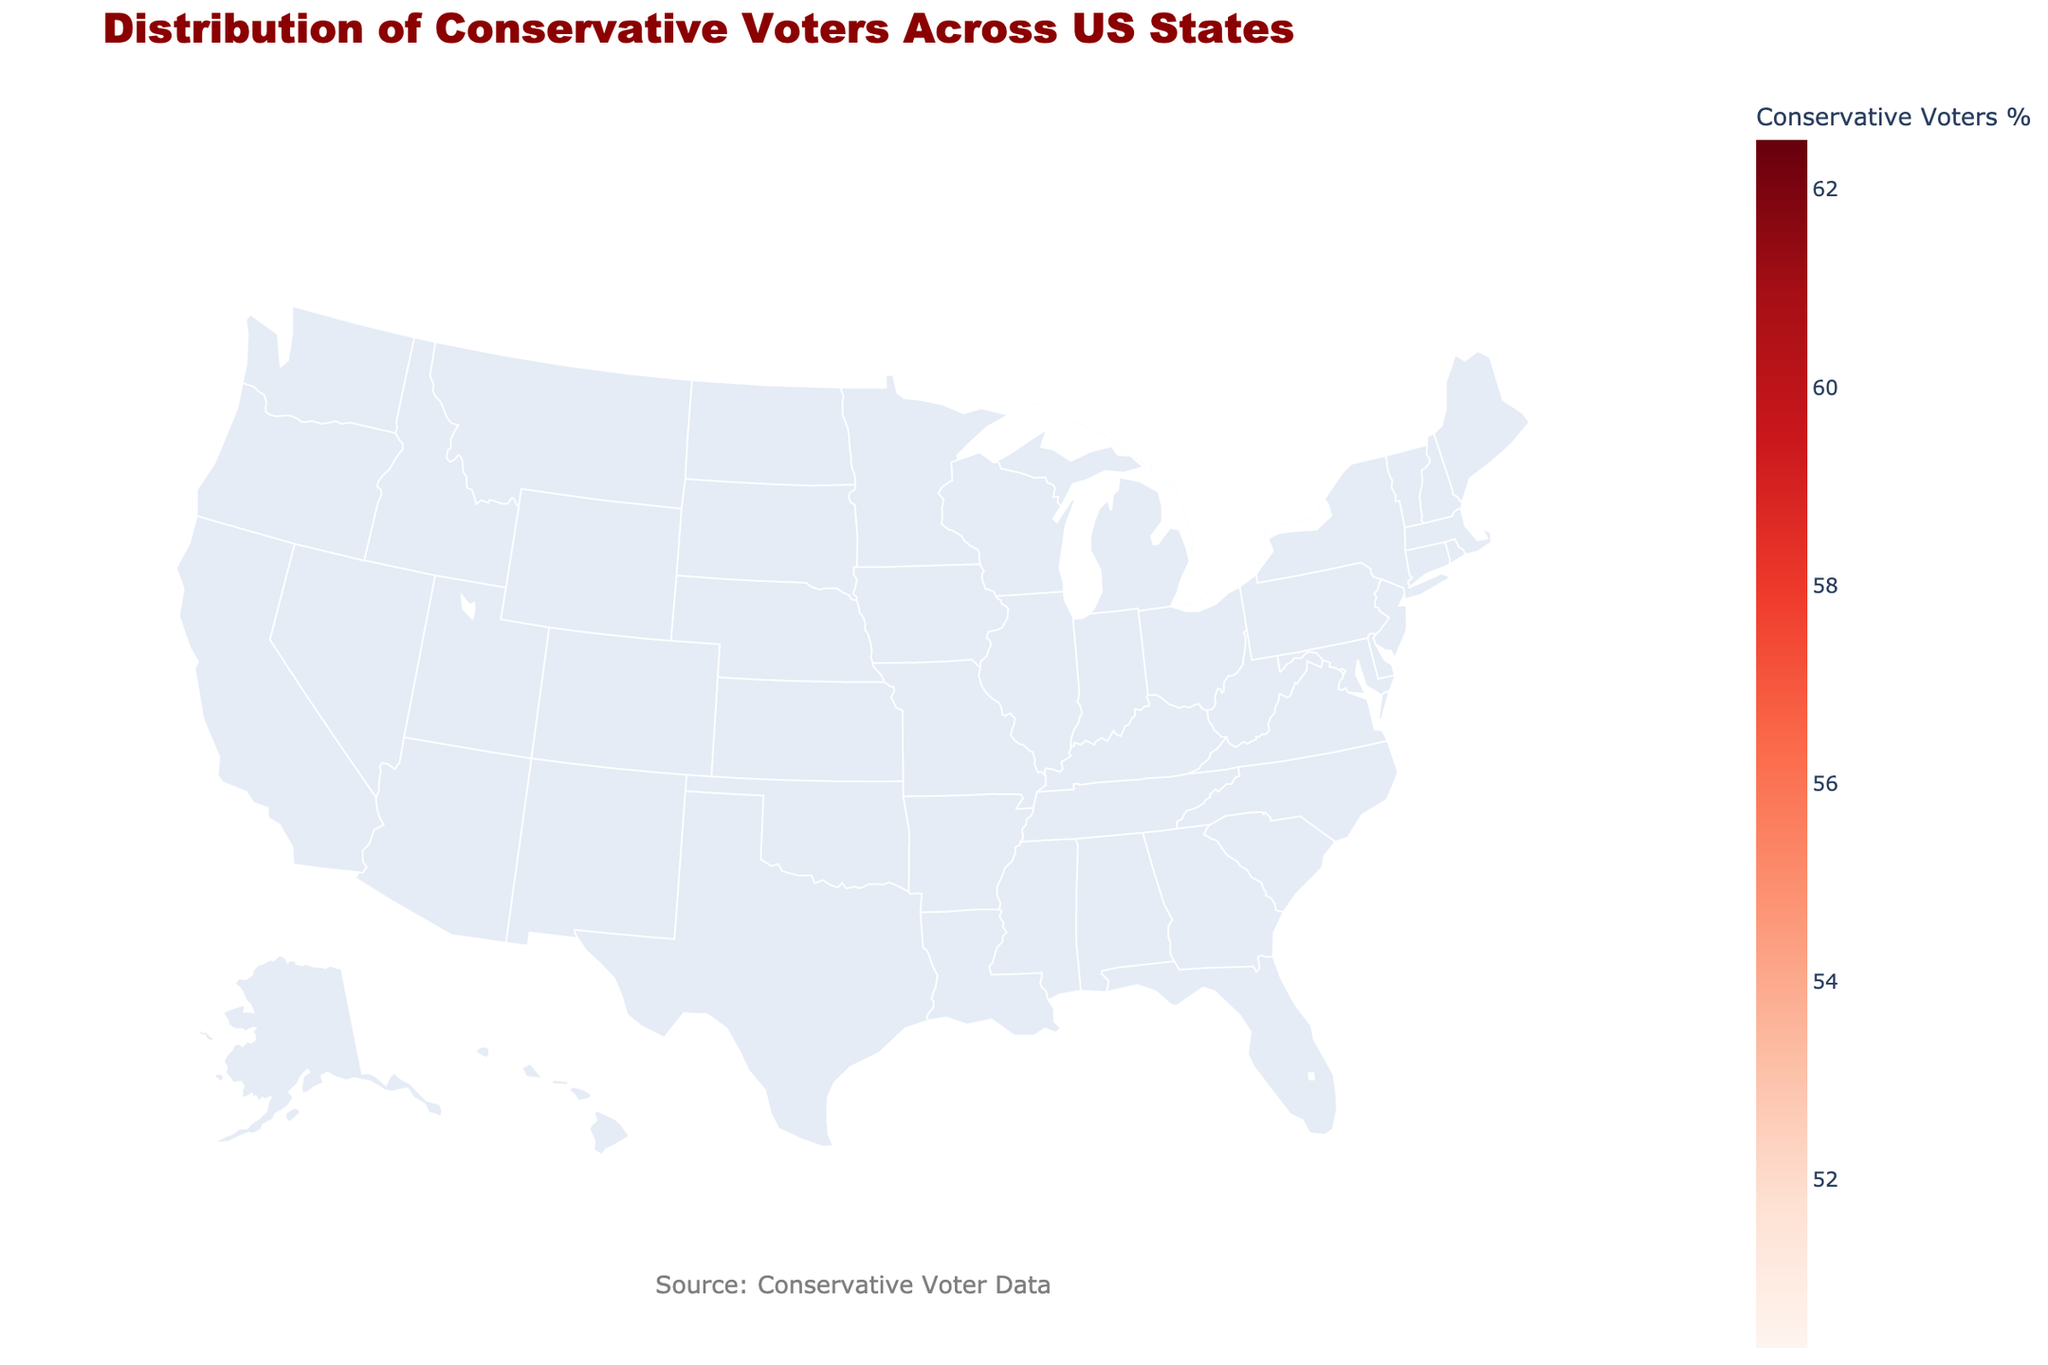What is the title of the plot? The title of the plot is displayed at the top and reads "Distribution of Conservative Voters Across US States".
Answer: Distribution of Conservative Voters Across US States Which state has the highest percentage of conservative voters? By comparing the percentages provided for each state on the plot, Kentucky has the highest percentage of conservative voters at 62.5%.
Answer: Kentucky What is the percentage of conservative voters in Texas who are aged 30-44? The text information for Texas indicates that the percentage of conservative voters aged 30-44 is 45%.
Answer: 45% Which age group in Alabama has the highest percentage of conservative voters? By looking at the age breakdown for Alabama, the age group 65+ has the highest percentage of conservative voters at 72%.
Answer: 65+ Compare the percentage of conservative voters aged 18-29 in Ohio to Florida. Which state has a higher percentage? Ohio has 31% of conservative voters aged 18-29, while Florida has 30%. Therefore, Ohio has a slightly higher percentage.
Answer: Ohio What is the average percentage of conservative voters among the states listed? Sum up the conservative voters percentage for each state and divide by the number of states: (52.1 + 51.2 + 53.3 + 50.8 + 50.3 + 57.0 + 60.7 + 62.1 + 62.5 + 54.9) / 10 = 54.49%
Answer: 54.49% Which state has the smallest difference in percentages between conservative voters with just high school education and those with some college education? Calculate the difference for each state and compare: Texas (4%), Florida (3%), Ohio (4%), Georgia (5%), North Carolina (4%), Indiana (4%), Tennessee (4%), Alabama (4%), Kentucky (4%), and South Carolina (4%). Florida has the smallest difference at 3%.
Answer: Florida Is there any state where conservative voters with post-graduate education comprise at least 50%? By checking the text details of each state, none of the states have 50% or more conservative voters with post-graduate education.
Answer: No Which state among the listed has the highest percentage of conservative voters aged 45-64? The data shows Kentucky has the highest percentage of conservative voters aged 45-64 at 67%.
Answer: Kentucky Is there a consistent trend in the percentage of conservative voters based on educational level? Yes, as education level increases (from high school to postgraduate), the percentage of conservative voters generally decreases across the states listed.
Answer: Yes 